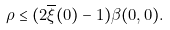Convert formula to latex. <formula><loc_0><loc_0><loc_500><loc_500>\rho \leq ( 2 \overline { \xi } ( 0 ) - 1 ) \beta ( 0 , 0 ) .</formula> 